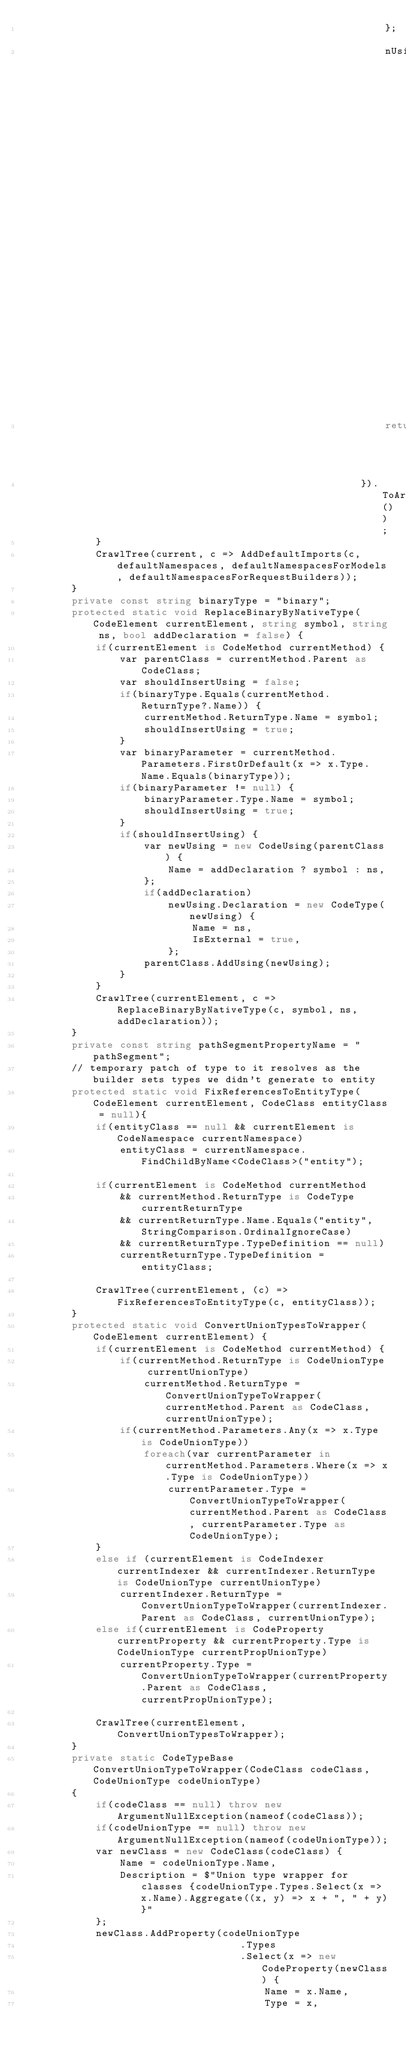<code> <loc_0><loc_0><loc_500><loc_500><_C#_>                                                            };
                                                            nUsing.Declaration = new CodeType(nUsing) { Name = x.Item2, IsExternal = true };
                                                            return nUsing;
                                                        }).ToArray());
            }
            CrawlTree(current, c => AddDefaultImports(c, defaultNamespaces, defaultNamespacesForModels, defaultNamespacesForRequestBuilders));
        }
        private const string binaryType = "binary";
        protected static void ReplaceBinaryByNativeType(CodeElement currentElement, string symbol, string ns, bool addDeclaration = false) {
            if(currentElement is CodeMethod currentMethod) {
                var parentClass = currentMethod.Parent as CodeClass;
                var shouldInsertUsing = false;
                if(binaryType.Equals(currentMethod.ReturnType?.Name)) {
                    currentMethod.ReturnType.Name = symbol;
                    shouldInsertUsing = true;
                }
                var binaryParameter = currentMethod.Parameters.FirstOrDefault(x => x.Type.Name.Equals(binaryType));
                if(binaryParameter != null) {
                    binaryParameter.Type.Name = symbol;
                    shouldInsertUsing = true;
                }
                if(shouldInsertUsing) {
                    var newUsing = new CodeUsing(parentClass) {
                        Name = addDeclaration ? symbol : ns,
                    };
                    if(addDeclaration)
                        newUsing.Declaration = new CodeType(newUsing) {
                            Name = ns,
                            IsExternal = true,
                        };
                    parentClass.AddUsing(newUsing);
                }
            }
            CrawlTree(currentElement, c => ReplaceBinaryByNativeType(c, symbol, ns, addDeclaration));
        }
        private const string pathSegmentPropertyName = "pathSegment";
        // temporary patch of type to it resolves as the builder sets types we didn't generate to entity
        protected static void FixReferencesToEntityType(CodeElement currentElement, CodeClass entityClass = null){
            if(entityClass == null && currentElement is CodeNamespace currentNamespace)
                entityClass = currentNamespace.FindChildByName<CodeClass>("entity");

            if(currentElement is CodeMethod currentMethod 
                && currentMethod.ReturnType is CodeType currentReturnType
                && currentReturnType.Name.Equals("entity", StringComparison.OrdinalIgnoreCase)
                && currentReturnType.TypeDefinition == null)
                currentReturnType.TypeDefinition = entityClass;

            CrawlTree(currentElement, (c) => FixReferencesToEntityType(c, entityClass));
        }
        protected static void ConvertUnionTypesToWrapper(CodeElement currentElement) {
            if(currentElement is CodeMethod currentMethod) {
                if(currentMethod.ReturnType is CodeUnionType currentUnionType)
                    currentMethod.ReturnType = ConvertUnionTypeToWrapper(currentMethod.Parent as CodeClass, currentUnionType);
                if(currentMethod.Parameters.Any(x => x.Type is CodeUnionType))
                    foreach(var currentParameter in currentMethod.Parameters.Where(x => x.Type is CodeUnionType))
                        currentParameter.Type = ConvertUnionTypeToWrapper(currentMethod.Parent as CodeClass, currentParameter.Type as CodeUnionType);
            }
            else if (currentElement is CodeIndexer currentIndexer && currentIndexer.ReturnType is CodeUnionType currentUnionType)
                currentIndexer.ReturnType = ConvertUnionTypeToWrapper(currentIndexer.Parent as CodeClass, currentUnionType);
            else if(currentElement is CodeProperty currentProperty && currentProperty.Type is CodeUnionType currentPropUnionType)
                currentProperty.Type = ConvertUnionTypeToWrapper(currentProperty.Parent as CodeClass, currentPropUnionType);

            CrawlTree(currentElement, ConvertUnionTypesToWrapper);
        }
        private static CodeTypeBase ConvertUnionTypeToWrapper(CodeClass codeClass, CodeUnionType codeUnionType)
        {
            if(codeClass == null) throw new ArgumentNullException(nameof(codeClass));
            if(codeUnionType == null) throw new ArgumentNullException(nameof(codeUnionType));
            var newClass = new CodeClass(codeClass) {
                Name = codeUnionType.Name,
                Description = $"Union type wrapper for classes {codeUnionType.Types.Select(x => x.Name).Aggregate((x, y) => x + ", " + y)}"
            };
            newClass.AddProperty(codeUnionType
                                    .Types
                                    .Select(x => new CodeProperty(newClass) {
                                        Name = x.Name,
                                        Type = x,</code> 